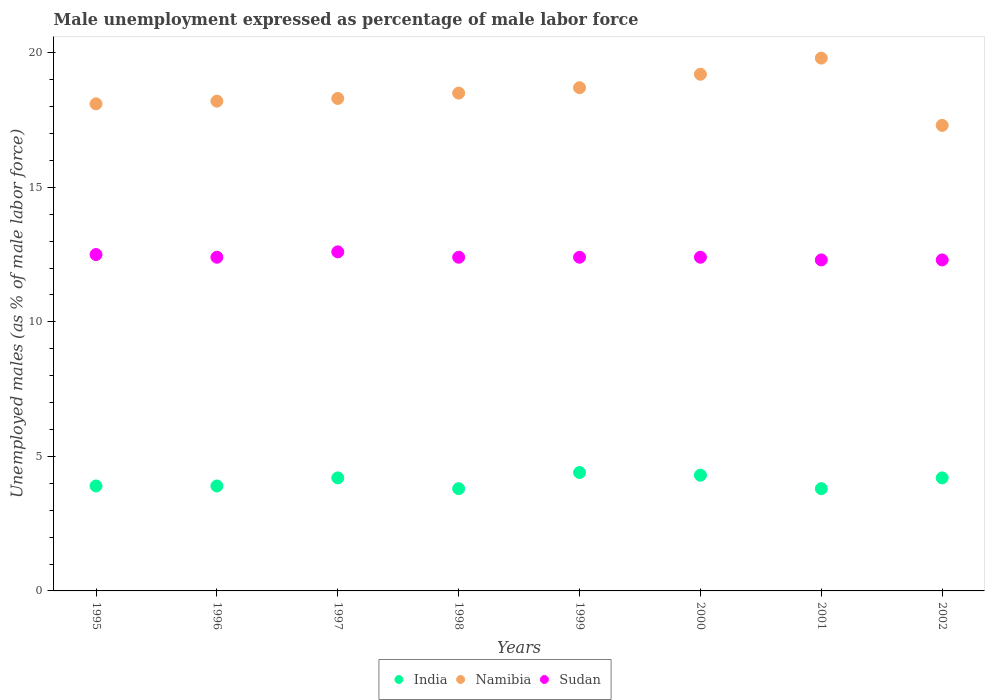What is the unemployment in males in in Sudan in 1999?
Provide a succinct answer. 12.4. Across all years, what is the maximum unemployment in males in in Sudan?
Keep it short and to the point. 12.6. Across all years, what is the minimum unemployment in males in in Sudan?
Your answer should be very brief. 12.3. What is the total unemployment in males in in Namibia in the graph?
Your answer should be compact. 148.1. What is the difference between the unemployment in males in in India in 1998 and the unemployment in males in in Sudan in 1997?
Your answer should be compact. -8.8. What is the average unemployment in males in in India per year?
Keep it short and to the point. 4.06. In the year 1998, what is the difference between the unemployment in males in in India and unemployment in males in in Sudan?
Your response must be concise. -8.6. What is the ratio of the unemployment in males in in Sudan in 1996 to that in 2000?
Offer a terse response. 1. Is the unemployment in males in in Sudan in 1995 less than that in 1997?
Provide a short and direct response. Yes. What is the difference between the highest and the second highest unemployment in males in in Sudan?
Provide a short and direct response. 0.1. What is the difference between the highest and the lowest unemployment in males in in Sudan?
Keep it short and to the point. 0.3. Is it the case that in every year, the sum of the unemployment in males in in India and unemployment in males in in Namibia  is greater than the unemployment in males in in Sudan?
Offer a very short reply. Yes. Does the unemployment in males in in Namibia monotonically increase over the years?
Make the answer very short. No. Is the unemployment in males in in Namibia strictly greater than the unemployment in males in in India over the years?
Offer a very short reply. Yes. How many dotlines are there?
Your answer should be very brief. 3. Where does the legend appear in the graph?
Offer a very short reply. Bottom center. How are the legend labels stacked?
Keep it short and to the point. Horizontal. What is the title of the graph?
Your response must be concise. Male unemployment expressed as percentage of male labor force. Does "Chile" appear as one of the legend labels in the graph?
Provide a short and direct response. No. What is the label or title of the Y-axis?
Your answer should be compact. Unemployed males (as % of male labor force). What is the Unemployed males (as % of male labor force) in India in 1995?
Offer a terse response. 3.9. What is the Unemployed males (as % of male labor force) of Namibia in 1995?
Keep it short and to the point. 18.1. What is the Unemployed males (as % of male labor force) in India in 1996?
Ensure brevity in your answer.  3.9. What is the Unemployed males (as % of male labor force) of Namibia in 1996?
Give a very brief answer. 18.2. What is the Unemployed males (as % of male labor force) of Sudan in 1996?
Ensure brevity in your answer.  12.4. What is the Unemployed males (as % of male labor force) of India in 1997?
Make the answer very short. 4.2. What is the Unemployed males (as % of male labor force) in Namibia in 1997?
Your answer should be very brief. 18.3. What is the Unemployed males (as % of male labor force) in Sudan in 1997?
Provide a short and direct response. 12.6. What is the Unemployed males (as % of male labor force) of India in 1998?
Provide a short and direct response. 3.8. What is the Unemployed males (as % of male labor force) of Sudan in 1998?
Your response must be concise. 12.4. What is the Unemployed males (as % of male labor force) of India in 1999?
Ensure brevity in your answer.  4.4. What is the Unemployed males (as % of male labor force) of Namibia in 1999?
Your answer should be very brief. 18.7. What is the Unemployed males (as % of male labor force) of Sudan in 1999?
Make the answer very short. 12.4. What is the Unemployed males (as % of male labor force) in India in 2000?
Keep it short and to the point. 4.3. What is the Unemployed males (as % of male labor force) in Namibia in 2000?
Offer a very short reply. 19.2. What is the Unemployed males (as % of male labor force) in Sudan in 2000?
Your answer should be compact. 12.4. What is the Unemployed males (as % of male labor force) in India in 2001?
Your response must be concise. 3.8. What is the Unemployed males (as % of male labor force) of Namibia in 2001?
Your answer should be compact. 19.8. What is the Unemployed males (as % of male labor force) of Sudan in 2001?
Ensure brevity in your answer.  12.3. What is the Unemployed males (as % of male labor force) in India in 2002?
Provide a short and direct response. 4.2. What is the Unemployed males (as % of male labor force) in Namibia in 2002?
Offer a terse response. 17.3. What is the Unemployed males (as % of male labor force) of Sudan in 2002?
Provide a succinct answer. 12.3. Across all years, what is the maximum Unemployed males (as % of male labor force) of India?
Your answer should be compact. 4.4. Across all years, what is the maximum Unemployed males (as % of male labor force) in Namibia?
Make the answer very short. 19.8. Across all years, what is the maximum Unemployed males (as % of male labor force) of Sudan?
Offer a very short reply. 12.6. Across all years, what is the minimum Unemployed males (as % of male labor force) of India?
Provide a succinct answer. 3.8. Across all years, what is the minimum Unemployed males (as % of male labor force) in Namibia?
Your answer should be compact. 17.3. Across all years, what is the minimum Unemployed males (as % of male labor force) in Sudan?
Your response must be concise. 12.3. What is the total Unemployed males (as % of male labor force) in India in the graph?
Offer a very short reply. 32.5. What is the total Unemployed males (as % of male labor force) of Namibia in the graph?
Make the answer very short. 148.1. What is the total Unemployed males (as % of male labor force) of Sudan in the graph?
Keep it short and to the point. 99.3. What is the difference between the Unemployed males (as % of male labor force) in Sudan in 1995 and that in 1996?
Your response must be concise. 0.1. What is the difference between the Unemployed males (as % of male labor force) in India in 1995 and that in 1997?
Provide a short and direct response. -0.3. What is the difference between the Unemployed males (as % of male labor force) in India in 1995 and that in 1998?
Give a very brief answer. 0.1. What is the difference between the Unemployed males (as % of male labor force) of India in 1995 and that in 1999?
Your answer should be compact. -0.5. What is the difference between the Unemployed males (as % of male labor force) of Sudan in 1995 and that in 1999?
Your answer should be compact. 0.1. What is the difference between the Unemployed males (as % of male labor force) in Sudan in 1995 and that in 2000?
Give a very brief answer. 0.1. What is the difference between the Unemployed males (as % of male labor force) in Namibia in 1995 and that in 2001?
Ensure brevity in your answer.  -1.7. What is the difference between the Unemployed males (as % of male labor force) of India in 1995 and that in 2002?
Give a very brief answer. -0.3. What is the difference between the Unemployed males (as % of male labor force) of Sudan in 1995 and that in 2002?
Offer a very short reply. 0.2. What is the difference between the Unemployed males (as % of male labor force) of India in 1996 and that in 1997?
Make the answer very short. -0.3. What is the difference between the Unemployed males (as % of male labor force) in India in 1996 and that in 1998?
Make the answer very short. 0.1. What is the difference between the Unemployed males (as % of male labor force) of Namibia in 1996 and that in 1998?
Your answer should be compact. -0.3. What is the difference between the Unemployed males (as % of male labor force) of Namibia in 1996 and that in 1999?
Your answer should be compact. -0.5. What is the difference between the Unemployed males (as % of male labor force) in India in 1996 and that in 2000?
Make the answer very short. -0.4. What is the difference between the Unemployed males (as % of male labor force) in Namibia in 1996 and that in 2000?
Your answer should be very brief. -1. What is the difference between the Unemployed males (as % of male labor force) in India in 1996 and that in 2001?
Your response must be concise. 0.1. What is the difference between the Unemployed males (as % of male labor force) in Sudan in 1996 and that in 2001?
Give a very brief answer. 0.1. What is the difference between the Unemployed males (as % of male labor force) of Namibia in 1997 and that in 1998?
Give a very brief answer. -0.2. What is the difference between the Unemployed males (as % of male labor force) in Sudan in 1997 and that in 1998?
Offer a terse response. 0.2. What is the difference between the Unemployed males (as % of male labor force) in Namibia in 1997 and that in 1999?
Keep it short and to the point. -0.4. What is the difference between the Unemployed males (as % of male labor force) of Sudan in 1997 and that in 2000?
Keep it short and to the point. 0.2. What is the difference between the Unemployed males (as % of male labor force) of India in 1997 and that in 2001?
Ensure brevity in your answer.  0.4. What is the difference between the Unemployed males (as % of male labor force) of Sudan in 1997 and that in 2001?
Provide a succinct answer. 0.3. What is the difference between the Unemployed males (as % of male labor force) in Sudan in 1997 and that in 2002?
Provide a short and direct response. 0.3. What is the difference between the Unemployed males (as % of male labor force) in Namibia in 1998 and that in 1999?
Give a very brief answer. -0.2. What is the difference between the Unemployed males (as % of male labor force) in Sudan in 1998 and that in 1999?
Keep it short and to the point. 0. What is the difference between the Unemployed males (as % of male labor force) in Namibia in 1998 and that in 2000?
Keep it short and to the point. -0.7. What is the difference between the Unemployed males (as % of male labor force) in Sudan in 1998 and that in 2000?
Your answer should be compact. 0. What is the difference between the Unemployed males (as % of male labor force) of Namibia in 1998 and that in 2001?
Keep it short and to the point. -1.3. What is the difference between the Unemployed males (as % of male labor force) in Sudan in 1998 and that in 2001?
Provide a short and direct response. 0.1. What is the difference between the Unemployed males (as % of male labor force) of Namibia in 1999 and that in 2001?
Your response must be concise. -1.1. What is the difference between the Unemployed males (as % of male labor force) in Sudan in 1999 and that in 2001?
Keep it short and to the point. 0.1. What is the difference between the Unemployed males (as % of male labor force) of India in 1999 and that in 2002?
Your response must be concise. 0.2. What is the difference between the Unemployed males (as % of male labor force) of India in 2000 and that in 2001?
Provide a succinct answer. 0.5. What is the difference between the Unemployed males (as % of male labor force) in Sudan in 2000 and that in 2001?
Your answer should be very brief. 0.1. What is the difference between the Unemployed males (as % of male labor force) in India in 2000 and that in 2002?
Provide a succinct answer. 0.1. What is the difference between the Unemployed males (as % of male labor force) in India in 1995 and the Unemployed males (as % of male labor force) in Namibia in 1996?
Keep it short and to the point. -14.3. What is the difference between the Unemployed males (as % of male labor force) in Namibia in 1995 and the Unemployed males (as % of male labor force) in Sudan in 1996?
Offer a terse response. 5.7. What is the difference between the Unemployed males (as % of male labor force) in India in 1995 and the Unemployed males (as % of male labor force) in Namibia in 1997?
Ensure brevity in your answer.  -14.4. What is the difference between the Unemployed males (as % of male labor force) of India in 1995 and the Unemployed males (as % of male labor force) of Namibia in 1998?
Your response must be concise. -14.6. What is the difference between the Unemployed males (as % of male labor force) of India in 1995 and the Unemployed males (as % of male labor force) of Sudan in 1998?
Offer a very short reply. -8.5. What is the difference between the Unemployed males (as % of male labor force) of Namibia in 1995 and the Unemployed males (as % of male labor force) of Sudan in 1998?
Keep it short and to the point. 5.7. What is the difference between the Unemployed males (as % of male labor force) of India in 1995 and the Unemployed males (as % of male labor force) of Namibia in 1999?
Offer a very short reply. -14.8. What is the difference between the Unemployed males (as % of male labor force) in Namibia in 1995 and the Unemployed males (as % of male labor force) in Sudan in 1999?
Make the answer very short. 5.7. What is the difference between the Unemployed males (as % of male labor force) in India in 1995 and the Unemployed males (as % of male labor force) in Namibia in 2000?
Offer a terse response. -15.3. What is the difference between the Unemployed males (as % of male labor force) in India in 1995 and the Unemployed males (as % of male labor force) in Sudan in 2000?
Give a very brief answer. -8.5. What is the difference between the Unemployed males (as % of male labor force) in India in 1995 and the Unemployed males (as % of male labor force) in Namibia in 2001?
Keep it short and to the point. -15.9. What is the difference between the Unemployed males (as % of male labor force) in Namibia in 1995 and the Unemployed males (as % of male labor force) in Sudan in 2001?
Provide a short and direct response. 5.8. What is the difference between the Unemployed males (as % of male labor force) of Namibia in 1995 and the Unemployed males (as % of male labor force) of Sudan in 2002?
Your answer should be compact. 5.8. What is the difference between the Unemployed males (as % of male labor force) in India in 1996 and the Unemployed males (as % of male labor force) in Namibia in 1997?
Provide a short and direct response. -14.4. What is the difference between the Unemployed males (as % of male labor force) in India in 1996 and the Unemployed males (as % of male labor force) in Sudan in 1997?
Your response must be concise. -8.7. What is the difference between the Unemployed males (as % of male labor force) in India in 1996 and the Unemployed males (as % of male labor force) in Namibia in 1998?
Offer a very short reply. -14.6. What is the difference between the Unemployed males (as % of male labor force) in India in 1996 and the Unemployed males (as % of male labor force) in Sudan in 1998?
Give a very brief answer. -8.5. What is the difference between the Unemployed males (as % of male labor force) in India in 1996 and the Unemployed males (as % of male labor force) in Namibia in 1999?
Your answer should be compact. -14.8. What is the difference between the Unemployed males (as % of male labor force) in Namibia in 1996 and the Unemployed males (as % of male labor force) in Sudan in 1999?
Give a very brief answer. 5.8. What is the difference between the Unemployed males (as % of male labor force) of India in 1996 and the Unemployed males (as % of male labor force) of Namibia in 2000?
Keep it short and to the point. -15.3. What is the difference between the Unemployed males (as % of male labor force) of India in 1996 and the Unemployed males (as % of male labor force) of Sudan in 2000?
Your answer should be compact. -8.5. What is the difference between the Unemployed males (as % of male labor force) of India in 1996 and the Unemployed males (as % of male labor force) of Namibia in 2001?
Provide a succinct answer. -15.9. What is the difference between the Unemployed males (as % of male labor force) in India in 1996 and the Unemployed males (as % of male labor force) in Sudan in 2001?
Your answer should be very brief. -8.4. What is the difference between the Unemployed males (as % of male labor force) in Namibia in 1996 and the Unemployed males (as % of male labor force) in Sudan in 2001?
Offer a terse response. 5.9. What is the difference between the Unemployed males (as % of male labor force) of India in 1997 and the Unemployed males (as % of male labor force) of Namibia in 1998?
Give a very brief answer. -14.3. What is the difference between the Unemployed males (as % of male labor force) of India in 1997 and the Unemployed males (as % of male labor force) of Sudan in 1999?
Ensure brevity in your answer.  -8.2. What is the difference between the Unemployed males (as % of male labor force) of India in 1997 and the Unemployed males (as % of male labor force) of Namibia in 2000?
Make the answer very short. -15. What is the difference between the Unemployed males (as % of male labor force) of India in 1997 and the Unemployed males (as % of male labor force) of Sudan in 2000?
Ensure brevity in your answer.  -8.2. What is the difference between the Unemployed males (as % of male labor force) of Namibia in 1997 and the Unemployed males (as % of male labor force) of Sudan in 2000?
Your answer should be very brief. 5.9. What is the difference between the Unemployed males (as % of male labor force) of India in 1997 and the Unemployed males (as % of male labor force) of Namibia in 2001?
Offer a very short reply. -15.6. What is the difference between the Unemployed males (as % of male labor force) in Namibia in 1997 and the Unemployed males (as % of male labor force) in Sudan in 2001?
Your response must be concise. 6. What is the difference between the Unemployed males (as % of male labor force) of India in 1997 and the Unemployed males (as % of male labor force) of Sudan in 2002?
Your response must be concise. -8.1. What is the difference between the Unemployed males (as % of male labor force) in India in 1998 and the Unemployed males (as % of male labor force) in Namibia in 1999?
Keep it short and to the point. -14.9. What is the difference between the Unemployed males (as % of male labor force) of Namibia in 1998 and the Unemployed males (as % of male labor force) of Sudan in 1999?
Your response must be concise. 6.1. What is the difference between the Unemployed males (as % of male labor force) in India in 1998 and the Unemployed males (as % of male labor force) in Namibia in 2000?
Make the answer very short. -15.4. What is the difference between the Unemployed males (as % of male labor force) of India in 1998 and the Unemployed males (as % of male labor force) of Sudan in 2000?
Provide a short and direct response. -8.6. What is the difference between the Unemployed males (as % of male labor force) of Namibia in 1998 and the Unemployed males (as % of male labor force) of Sudan in 2000?
Give a very brief answer. 6.1. What is the difference between the Unemployed males (as % of male labor force) in India in 1998 and the Unemployed males (as % of male labor force) in Namibia in 2001?
Provide a short and direct response. -16. What is the difference between the Unemployed males (as % of male labor force) in Namibia in 1998 and the Unemployed males (as % of male labor force) in Sudan in 2001?
Your answer should be very brief. 6.2. What is the difference between the Unemployed males (as % of male labor force) in India in 1998 and the Unemployed males (as % of male labor force) in Sudan in 2002?
Your answer should be very brief. -8.5. What is the difference between the Unemployed males (as % of male labor force) of India in 1999 and the Unemployed males (as % of male labor force) of Namibia in 2000?
Provide a succinct answer. -14.8. What is the difference between the Unemployed males (as % of male labor force) in India in 1999 and the Unemployed males (as % of male labor force) in Sudan in 2000?
Provide a succinct answer. -8. What is the difference between the Unemployed males (as % of male labor force) in Namibia in 1999 and the Unemployed males (as % of male labor force) in Sudan in 2000?
Offer a terse response. 6.3. What is the difference between the Unemployed males (as % of male labor force) in India in 1999 and the Unemployed males (as % of male labor force) in Namibia in 2001?
Your response must be concise. -15.4. What is the difference between the Unemployed males (as % of male labor force) of India in 1999 and the Unemployed males (as % of male labor force) of Namibia in 2002?
Provide a succinct answer. -12.9. What is the difference between the Unemployed males (as % of male labor force) in India in 1999 and the Unemployed males (as % of male labor force) in Sudan in 2002?
Offer a terse response. -7.9. What is the difference between the Unemployed males (as % of male labor force) in Namibia in 1999 and the Unemployed males (as % of male labor force) in Sudan in 2002?
Provide a succinct answer. 6.4. What is the difference between the Unemployed males (as % of male labor force) of India in 2000 and the Unemployed males (as % of male labor force) of Namibia in 2001?
Your answer should be very brief. -15.5. What is the difference between the Unemployed males (as % of male labor force) of India in 2000 and the Unemployed males (as % of male labor force) of Sudan in 2001?
Provide a short and direct response. -8. What is the difference between the Unemployed males (as % of male labor force) in India in 2000 and the Unemployed males (as % of male labor force) in Namibia in 2002?
Offer a very short reply. -13. What is the difference between the Unemployed males (as % of male labor force) of India in 2000 and the Unemployed males (as % of male labor force) of Sudan in 2002?
Provide a short and direct response. -8. What is the difference between the Unemployed males (as % of male labor force) of India in 2001 and the Unemployed males (as % of male labor force) of Sudan in 2002?
Offer a terse response. -8.5. What is the average Unemployed males (as % of male labor force) in India per year?
Offer a very short reply. 4.06. What is the average Unemployed males (as % of male labor force) in Namibia per year?
Your answer should be compact. 18.51. What is the average Unemployed males (as % of male labor force) of Sudan per year?
Offer a terse response. 12.41. In the year 1995, what is the difference between the Unemployed males (as % of male labor force) in India and Unemployed males (as % of male labor force) in Namibia?
Make the answer very short. -14.2. In the year 1995, what is the difference between the Unemployed males (as % of male labor force) of India and Unemployed males (as % of male labor force) of Sudan?
Your answer should be compact. -8.6. In the year 1995, what is the difference between the Unemployed males (as % of male labor force) in Namibia and Unemployed males (as % of male labor force) in Sudan?
Your response must be concise. 5.6. In the year 1996, what is the difference between the Unemployed males (as % of male labor force) in India and Unemployed males (as % of male labor force) in Namibia?
Provide a succinct answer. -14.3. In the year 1996, what is the difference between the Unemployed males (as % of male labor force) in India and Unemployed males (as % of male labor force) in Sudan?
Make the answer very short. -8.5. In the year 1996, what is the difference between the Unemployed males (as % of male labor force) of Namibia and Unemployed males (as % of male labor force) of Sudan?
Ensure brevity in your answer.  5.8. In the year 1997, what is the difference between the Unemployed males (as % of male labor force) in India and Unemployed males (as % of male labor force) in Namibia?
Your answer should be very brief. -14.1. In the year 1997, what is the difference between the Unemployed males (as % of male labor force) of India and Unemployed males (as % of male labor force) of Sudan?
Your response must be concise. -8.4. In the year 1998, what is the difference between the Unemployed males (as % of male labor force) in India and Unemployed males (as % of male labor force) in Namibia?
Provide a short and direct response. -14.7. In the year 1998, what is the difference between the Unemployed males (as % of male labor force) of India and Unemployed males (as % of male labor force) of Sudan?
Keep it short and to the point. -8.6. In the year 1998, what is the difference between the Unemployed males (as % of male labor force) of Namibia and Unemployed males (as % of male labor force) of Sudan?
Keep it short and to the point. 6.1. In the year 1999, what is the difference between the Unemployed males (as % of male labor force) of India and Unemployed males (as % of male labor force) of Namibia?
Offer a terse response. -14.3. In the year 1999, what is the difference between the Unemployed males (as % of male labor force) in Namibia and Unemployed males (as % of male labor force) in Sudan?
Your answer should be very brief. 6.3. In the year 2000, what is the difference between the Unemployed males (as % of male labor force) of India and Unemployed males (as % of male labor force) of Namibia?
Provide a short and direct response. -14.9. In the year 2000, what is the difference between the Unemployed males (as % of male labor force) in Namibia and Unemployed males (as % of male labor force) in Sudan?
Your answer should be very brief. 6.8. In the year 2001, what is the difference between the Unemployed males (as % of male labor force) of India and Unemployed males (as % of male labor force) of Namibia?
Offer a very short reply. -16. In the year 2001, what is the difference between the Unemployed males (as % of male labor force) in India and Unemployed males (as % of male labor force) in Sudan?
Ensure brevity in your answer.  -8.5. In the year 2002, what is the difference between the Unemployed males (as % of male labor force) of Namibia and Unemployed males (as % of male labor force) of Sudan?
Keep it short and to the point. 5. What is the ratio of the Unemployed males (as % of male labor force) of India in 1995 to that in 1997?
Give a very brief answer. 0.93. What is the ratio of the Unemployed males (as % of male labor force) in India in 1995 to that in 1998?
Keep it short and to the point. 1.03. What is the ratio of the Unemployed males (as % of male labor force) of Namibia in 1995 to that in 1998?
Keep it short and to the point. 0.98. What is the ratio of the Unemployed males (as % of male labor force) of Sudan in 1995 to that in 1998?
Keep it short and to the point. 1.01. What is the ratio of the Unemployed males (as % of male labor force) in India in 1995 to that in 1999?
Make the answer very short. 0.89. What is the ratio of the Unemployed males (as % of male labor force) in Namibia in 1995 to that in 1999?
Offer a very short reply. 0.97. What is the ratio of the Unemployed males (as % of male labor force) of Sudan in 1995 to that in 1999?
Offer a very short reply. 1.01. What is the ratio of the Unemployed males (as % of male labor force) in India in 1995 to that in 2000?
Your answer should be compact. 0.91. What is the ratio of the Unemployed males (as % of male labor force) of Namibia in 1995 to that in 2000?
Your answer should be compact. 0.94. What is the ratio of the Unemployed males (as % of male labor force) of India in 1995 to that in 2001?
Keep it short and to the point. 1.03. What is the ratio of the Unemployed males (as % of male labor force) in Namibia in 1995 to that in 2001?
Offer a very short reply. 0.91. What is the ratio of the Unemployed males (as % of male labor force) in Sudan in 1995 to that in 2001?
Your answer should be compact. 1.02. What is the ratio of the Unemployed males (as % of male labor force) of Namibia in 1995 to that in 2002?
Your response must be concise. 1.05. What is the ratio of the Unemployed males (as % of male labor force) in Sudan in 1995 to that in 2002?
Provide a succinct answer. 1.02. What is the ratio of the Unemployed males (as % of male labor force) of Namibia in 1996 to that in 1997?
Your answer should be compact. 0.99. What is the ratio of the Unemployed males (as % of male labor force) of Sudan in 1996 to that in 1997?
Your answer should be very brief. 0.98. What is the ratio of the Unemployed males (as % of male labor force) in India in 1996 to that in 1998?
Ensure brevity in your answer.  1.03. What is the ratio of the Unemployed males (as % of male labor force) of Namibia in 1996 to that in 1998?
Give a very brief answer. 0.98. What is the ratio of the Unemployed males (as % of male labor force) in Sudan in 1996 to that in 1998?
Your answer should be compact. 1. What is the ratio of the Unemployed males (as % of male labor force) in India in 1996 to that in 1999?
Offer a very short reply. 0.89. What is the ratio of the Unemployed males (as % of male labor force) in Namibia in 1996 to that in 1999?
Offer a very short reply. 0.97. What is the ratio of the Unemployed males (as % of male labor force) of India in 1996 to that in 2000?
Provide a succinct answer. 0.91. What is the ratio of the Unemployed males (as % of male labor force) of Namibia in 1996 to that in 2000?
Make the answer very short. 0.95. What is the ratio of the Unemployed males (as % of male labor force) of India in 1996 to that in 2001?
Offer a terse response. 1.03. What is the ratio of the Unemployed males (as % of male labor force) of Namibia in 1996 to that in 2001?
Provide a short and direct response. 0.92. What is the ratio of the Unemployed males (as % of male labor force) in India in 1996 to that in 2002?
Give a very brief answer. 0.93. What is the ratio of the Unemployed males (as % of male labor force) of Namibia in 1996 to that in 2002?
Offer a very short reply. 1.05. What is the ratio of the Unemployed males (as % of male labor force) in India in 1997 to that in 1998?
Make the answer very short. 1.11. What is the ratio of the Unemployed males (as % of male labor force) in Namibia in 1997 to that in 1998?
Your answer should be compact. 0.99. What is the ratio of the Unemployed males (as % of male labor force) in Sudan in 1997 to that in 1998?
Give a very brief answer. 1.02. What is the ratio of the Unemployed males (as % of male labor force) of India in 1997 to that in 1999?
Make the answer very short. 0.95. What is the ratio of the Unemployed males (as % of male labor force) in Namibia in 1997 to that in 1999?
Your answer should be very brief. 0.98. What is the ratio of the Unemployed males (as % of male labor force) in Sudan in 1997 to that in 1999?
Provide a short and direct response. 1.02. What is the ratio of the Unemployed males (as % of male labor force) in India in 1997 to that in 2000?
Offer a terse response. 0.98. What is the ratio of the Unemployed males (as % of male labor force) of Namibia in 1997 to that in 2000?
Offer a very short reply. 0.95. What is the ratio of the Unemployed males (as % of male labor force) in Sudan in 1997 to that in 2000?
Provide a succinct answer. 1.02. What is the ratio of the Unemployed males (as % of male labor force) in India in 1997 to that in 2001?
Offer a very short reply. 1.11. What is the ratio of the Unemployed males (as % of male labor force) of Namibia in 1997 to that in 2001?
Make the answer very short. 0.92. What is the ratio of the Unemployed males (as % of male labor force) of Sudan in 1997 to that in 2001?
Offer a very short reply. 1.02. What is the ratio of the Unemployed males (as % of male labor force) in India in 1997 to that in 2002?
Your answer should be very brief. 1. What is the ratio of the Unemployed males (as % of male labor force) of Namibia in 1997 to that in 2002?
Offer a very short reply. 1.06. What is the ratio of the Unemployed males (as % of male labor force) of Sudan in 1997 to that in 2002?
Your answer should be compact. 1.02. What is the ratio of the Unemployed males (as % of male labor force) in India in 1998 to that in 1999?
Keep it short and to the point. 0.86. What is the ratio of the Unemployed males (as % of male labor force) in Namibia in 1998 to that in 1999?
Provide a short and direct response. 0.99. What is the ratio of the Unemployed males (as % of male labor force) in Sudan in 1998 to that in 1999?
Offer a terse response. 1. What is the ratio of the Unemployed males (as % of male labor force) of India in 1998 to that in 2000?
Your answer should be very brief. 0.88. What is the ratio of the Unemployed males (as % of male labor force) of Namibia in 1998 to that in 2000?
Keep it short and to the point. 0.96. What is the ratio of the Unemployed males (as % of male labor force) in Sudan in 1998 to that in 2000?
Make the answer very short. 1. What is the ratio of the Unemployed males (as % of male labor force) of Namibia in 1998 to that in 2001?
Provide a succinct answer. 0.93. What is the ratio of the Unemployed males (as % of male labor force) of India in 1998 to that in 2002?
Provide a short and direct response. 0.9. What is the ratio of the Unemployed males (as % of male labor force) in Namibia in 1998 to that in 2002?
Your answer should be very brief. 1.07. What is the ratio of the Unemployed males (as % of male labor force) in India in 1999 to that in 2000?
Your answer should be compact. 1.02. What is the ratio of the Unemployed males (as % of male labor force) in India in 1999 to that in 2001?
Your answer should be compact. 1.16. What is the ratio of the Unemployed males (as % of male labor force) of Namibia in 1999 to that in 2001?
Your response must be concise. 0.94. What is the ratio of the Unemployed males (as % of male labor force) in India in 1999 to that in 2002?
Your answer should be compact. 1.05. What is the ratio of the Unemployed males (as % of male labor force) of Namibia in 1999 to that in 2002?
Give a very brief answer. 1.08. What is the ratio of the Unemployed males (as % of male labor force) in India in 2000 to that in 2001?
Keep it short and to the point. 1.13. What is the ratio of the Unemployed males (as % of male labor force) of Namibia in 2000 to that in 2001?
Give a very brief answer. 0.97. What is the ratio of the Unemployed males (as % of male labor force) of Sudan in 2000 to that in 2001?
Keep it short and to the point. 1.01. What is the ratio of the Unemployed males (as % of male labor force) of India in 2000 to that in 2002?
Your answer should be compact. 1.02. What is the ratio of the Unemployed males (as % of male labor force) of Namibia in 2000 to that in 2002?
Provide a succinct answer. 1.11. What is the ratio of the Unemployed males (as % of male labor force) in India in 2001 to that in 2002?
Provide a short and direct response. 0.9. What is the ratio of the Unemployed males (as % of male labor force) of Namibia in 2001 to that in 2002?
Offer a terse response. 1.14. What is the ratio of the Unemployed males (as % of male labor force) in Sudan in 2001 to that in 2002?
Your answer should be very brief. 1. What is the difference between the highest and the second highest Unemployed males (as % of male labor force) of India?
Your response must be concise. 0.1. What is the difference between the highest and the second highest Unemployed males (as % of male labor force) in Namibia?
Offer a terse response. 0.6. What is the difference between the highest and the second highest Unemployed males (as % of male labor force) in Sudan?
Ensure brevity in your answer.  0.1. What is the difference between the highest and the lowest Unemployed males (as % of male labor force) of India?
Offer a very short reply. 0.6. What is the difference between the highest and the lowest Unemployed males (as % of male labor force) in Namibia?
Your answer should be compact. 2.5. 